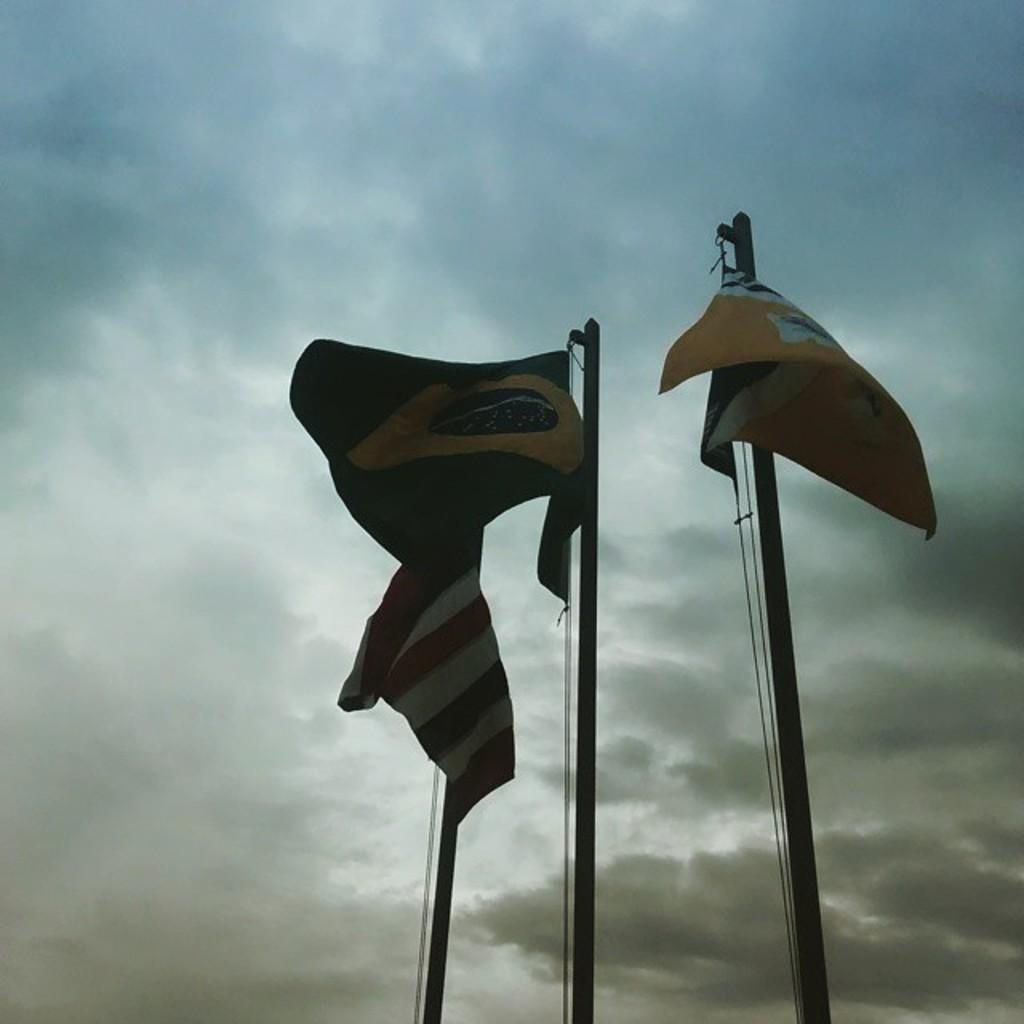What objects are on poles in the image? There are flags on poles in the image. What can be seen in the background of the image? The sky is visible in the background of the image. What is the condition of the sky in the image? Clouds are present in the sky. What type of toy can be seen falling from the sky in the image? There is no toy present in the image, nor is there anything falling from the sky. 